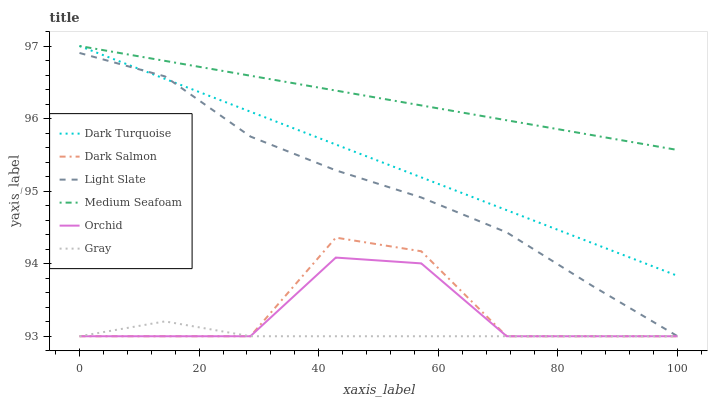Does Gray have the minimum area under the curve?
Answer yes or no. Yes. Does Medium Seafoam have the maximum area under the curve?
Answer yes or no. Yes. Does Light Slate have the minimum area under the curve?
Answer yes or no. No. Does Light Slate have the maximum area under the curve?
Answer yes or no. No. Is Medium Seafoam the smoothest?
Answer yes or no. Yes. Is Dark Salmon the roughest?
Answer yes or no. Yes. Is Light Slate the smoothest?
Answer yes or no. No. Is Light Slate the roughest?
Answer yes or no. No. Does Gray have the lowest value?
Answer yes or no. Yes. Does Dark Turquoise have the lowest value?
Answer yes or no. No. Does Medium Seafoam have the highest value?
Answer yes or no. Yes. Does Light Slate have the highest value?
Answer yes or no. No. Is Gray less than Medium Seafoam?
Answer yes or no. Yes. Is Dark Turquoise greater than Orchid?
Answer yes or no. Yes. Does Gray intersect Orchid?
Answer yes or no. Yes. Is Gray less than Orchid?
Answer yes or no. No. Is Gray greater than Orchid?
Answer yes or no. No. Does Gray intersect Medium Seafoam?
Answer yes or no. No. 